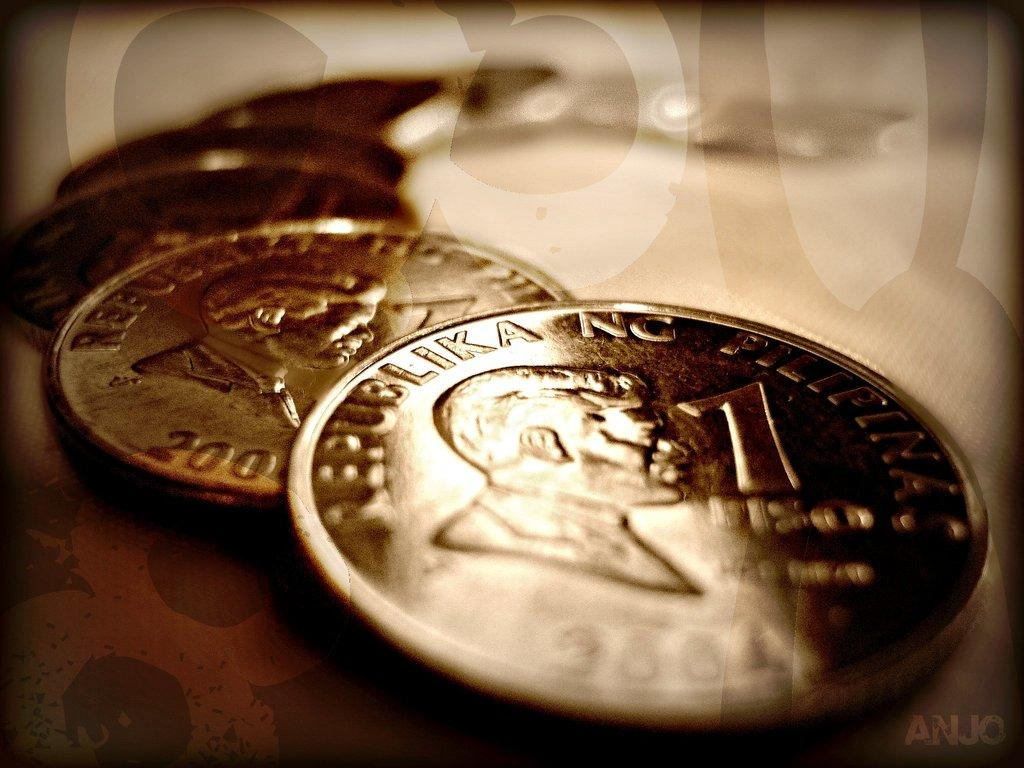<image>
Create a compact narrative representing the image presented. Several one cent coins of Republika NC from 2001 overlapping each other. 